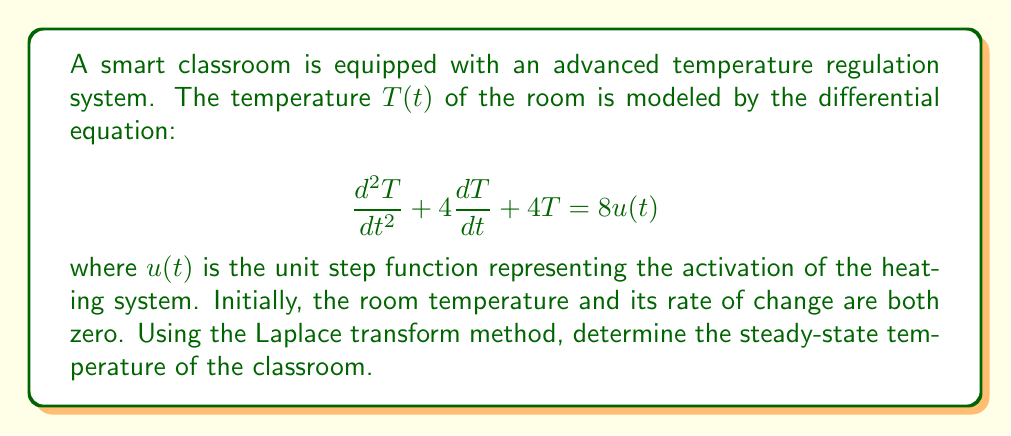Give your solution to this math problem. To solve this problem, we'll use the Laplace transform method:

1) First, let's take the Laplace transform of both sides of the equation:
   $$\mathcal{L}\left\{\frac{d^2T}{dt^2} + 4\frac{dT}{dt} + 4T\right\} = \mathcal{L}\{8u(t)\}$$

2) Using Laplace transform properties:
   $$[s^2T(s) - sT(0) - T'(0)] + 4[sT(s) - T(0)] + 4T(s) = \frac{8}{s}$$

3) Given initial conditions $T(0) = 0$ and $T'(0) = 0$:
   $$s^2T(s) + 4sT(s) + 4T(s) = \frac{8}{s}$$

4) Factoring out $T(s)$:
   $$T(s)(s^2 + 4s + 4) = \frac{8}{s}$$

5) Solving for $T(s)$:
   $$T(s) = \frac{8}{s(s^2 + 4s + 4)} = \frac{8}{s(s + 2)^2}$$

6) To find the steady-state temperature, we use the Final Value Theorem:
   $$\lim_{t \to \infty} T(t) = \lim_{s \to 0} sT(s)$$

7) Applying this to our $T(s)$:
   $$\lim_{s \to 0} s \cdot \frac{8}{s(s + 2)^2} = \lim_{s \to 0} \frac{8}{(s + 2)^2} = \frac{8}{4} = 2$$

Therefore, the steady-state temperature of the classroom is 2 units (e.g., 2°C above the initial temperature).
Answer: The steady-state temperature of the smart classroom is 2 units above the initial temperature. 